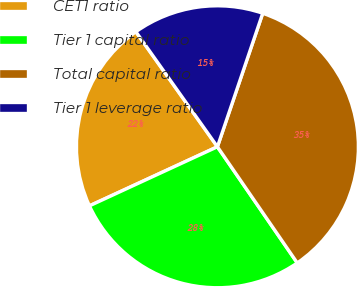Convert chart to OTSL. <chart><loc_0><loc_0><loc_500><loc_500><pie_chart><fcel>CET1 ratio<fcel>Tier 1 capital ratio<fcel>Total capital ratio<fcel>Tier 1 leverage ratio<nl><fcel>22.07%<fcel>27.7%<fcel>35.21%<fcel>15.02%<nl></chart> 